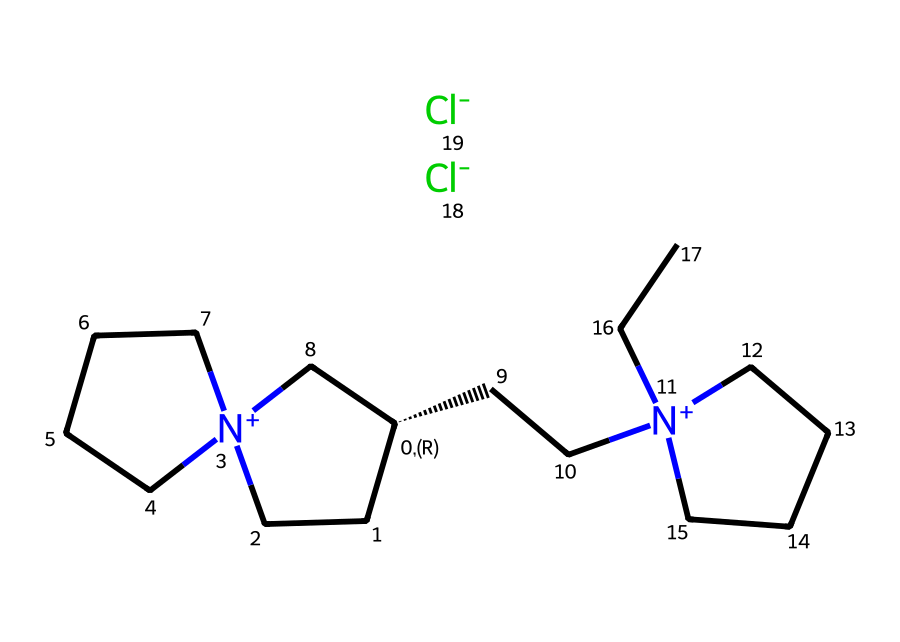What is the overall charge of this ionic liquid? The chemical structure contains two positively charged nitrogen atoms (indicated by [N+]) and a total of two chloride anions ([Cl-]). The positive charges from the two nitrogen atoms (2+) are balanced by the two chloride anions (2-), resulting in an overall neutral charge.
Answer: neutral What type of bonds are present in this compound? The compound features covalent bonds between carbon atoms and nitrogen atoms as part of the aliphatic carbon chains, and ionic bonds between the positively charged nitrogen ions and the negatively charged chloride ions.
Answer: covalent and ionic How many distinct carbon atoms are present in this chemical? By analyzing the structure, there are 12 carbon atoms in total in the molecular structure.
Answer: 12 What type of ions are present in this ionic liquid? The ionic liquid contains quaternary ammonium cations, which are characterized by the presence of positively charged nitrogen atoms, and chloride anions serving as the counterions.
Answer: quaternary ammonium and chloride What functional group can be inferred from the presence of the nitrogen atoms? The nitrogen atoms in the structure suggest the presence of ammonium functional groups, specifically indicating that the compound is a quaternary ammonium salt due to the nitrogen's positive charges.
Answer: ammonium What is the significance of the ionic nature of this liquid regarding its performance in glove treatments? The ionic nature provides specific properties such as low volatility and high thermal stability, which are essential for maintaining grip and performance in goalkeeper gloves by allowing for a stable interface between the glove material and moisture.
Answer: low volatility and high thermal stability 